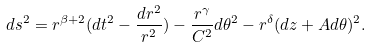<formula> <loc_0><loc_0><loc_500><loc_500>d s ^ { 2 } = r ^ { \beta + 2 } ( d t ^ { 2 } - \frac { d r ^ { 2 } } { r ^ { 2 } } ) - \frac { r ^ { \gamma } } { C ^ { 2 } } d \theta ^ { 2 } - r ^ { \delta } ( d z + A d \theta ) ^ { 2 } .</formula> 